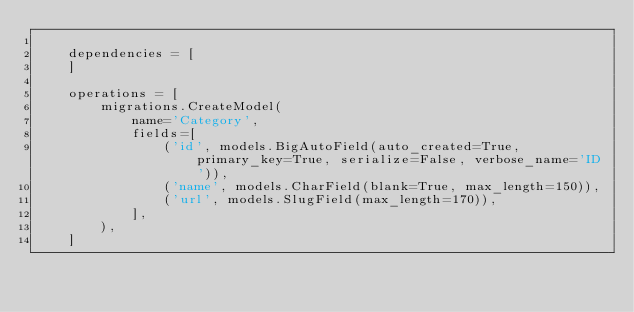<code> <loc_0><loc_0><loc_500><loc_500><_Python_>
    dependencies = [
    ]

    operations = [
        migrations.CreateModel(
            name='Category',
            fields=[
                ('id', models.BigAutoField(auto_created=True, primary_key=True, serialize=False, verbose_name='ID')),
                ('name', models.CharField(blank=True, max_length=150)),
                ('url', models.SlugField(max_length=170)),
            ],
        ),
    ]
</code> 